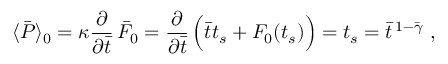Convert formula to latex. <formula><loc_0><loc_0><loc_500><loc_500>\langle \bar { P } \rangle _ { 0 } = \kappa { \frac { \partial } { \partial \bar { t } } } \, \bar { F } _ { 0 } = { \frac { \partial } { \partial \bar { t } } } \, \left ( \bar { t } t _ { s } + F _ { 0 } ( t _ { s } ) \right ) = t _ { s } = \bar { t } ^ { \, 1 - \bar { \gamma } } \ ,</formula> 